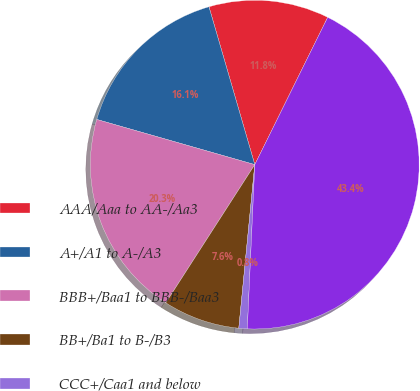<chart> <loc_0><loc_0><loc_500><loc_500><pie_chart><fcel>AAA/Aaa to AA-/Aa3<fcel>A+/A1 to A-/A3<fcel>BBB+/Baa1 to BBB-/Baa3<fcel>BB+/Ba1 to B-/B3<fcel>CCC+/Caa1 and below<fcel>Total<nl><fcel>11.81%<fcel>16.07%<fcel>20.33%<fcel>7.55%<fcel>0.83%<fcel>43.41%<nl></chart> 